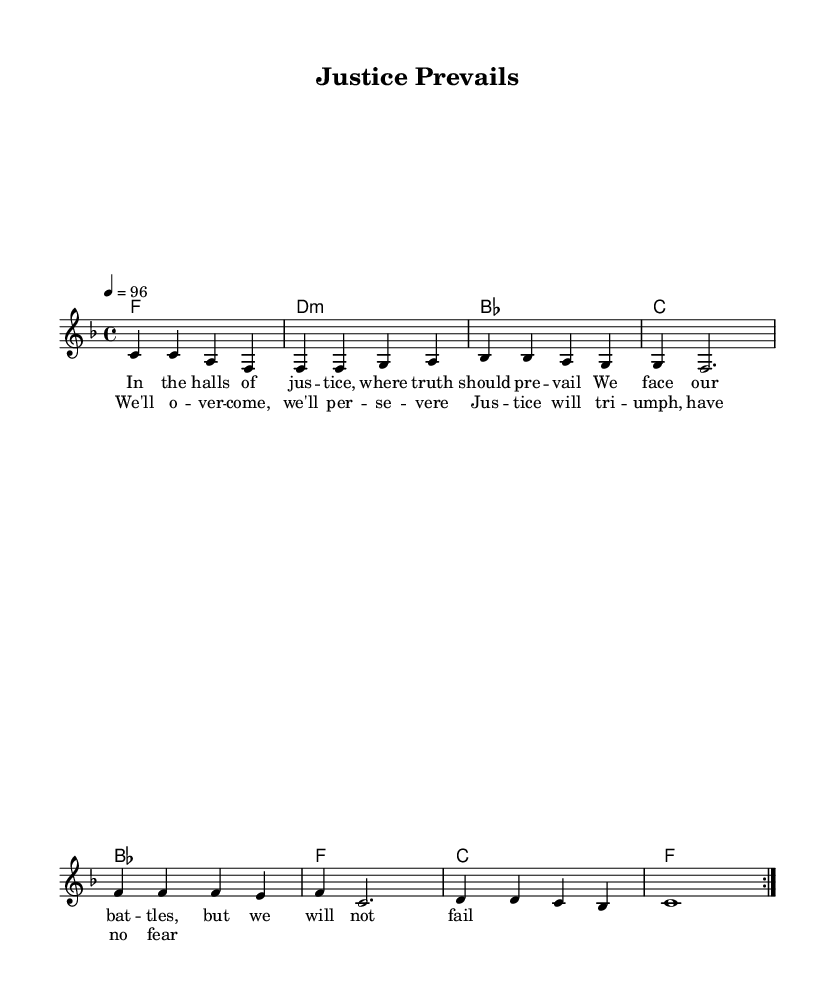What is the key signature of this music? The key signature shown in the music is F major, which has one flat (B flat). This can be identified by looking at the key signature indicator at the beginning of the score.
Answer: F major What is the time signature of this piece? The time signature is indicated as 4/4, meaning there are four beats in each measure and a quarter note receives one beat. This is found at the start of the sheet music.
Answer: 4/4 What is the tempo marking for this composition? The tempo marking is set at 96 beats per minute, as described in the tempo line. This indicates the speed at which the piece should be played.
Answer: 96 How many measures are in the repeated section (volta)? The repeated section consists of 8 measures, which are indicated by the volta repeat sign (the two dots and the instruction to repeat). Each measure can be counted from the beginning to the repeat sign.
Answer: 8 What is the first lyric line of the verse? The first lyric line of the verse is "In the halls of jus -- tice, where truth should pre -- vail," which can be found beneath the melody in the lyrics section.
Answer: In the halls of jus -- tice, where truth should pre -- vail How many different chords are used in the harmony section? The harmony section features 4 distinct chords: F, D minor, B flat, and C. Each chord is represented in its respective measure, and their names can be read off directly from the chord symbols at the beginning of each measure.
Answer: 4 What theme is primarily expressed in the chorus lyrics? The chorus expresses the theme of overcoming challenges and perseverance, as highlighted by the lyrics "We'll o -- ver -- come, we'll per -- se -- vere." This theme aligns with the overall message portrayed throughout the piece.
Answer: Overcoming challenges 